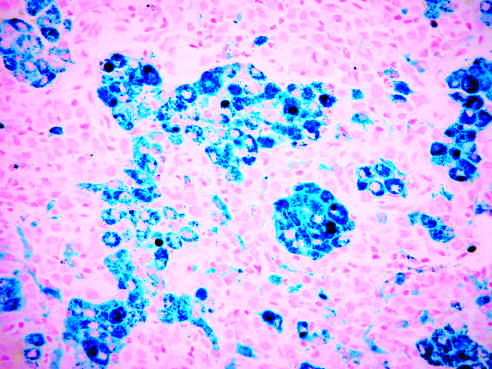has the acute myocardial infarct of the posterolateral left ventricle been stained with prussian blue, an iron stain that highlights the abundant intracellular hemo-siderin?
Answer the question using a single word or phrase. No 